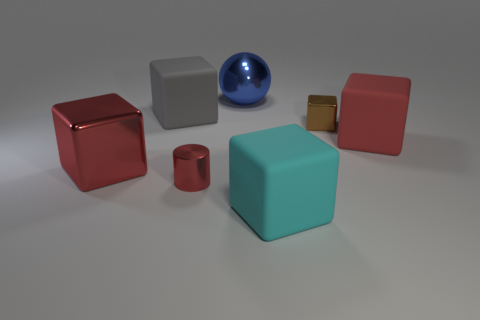Subtract all big red shiny cubes. How many cubes are left? 4 Subtract all brown blocks. How many blocks are left? 4 Subtract all green blocks. Subtract all yellow balls. How many blocks are left? 5 Add 2 metallic cylinders. How many objects exist? 9 Subtract all balls. How many objects are left? 6 Add 2 gray objects. How many gray objects are left? 3 Add 2 brown cubes. How many brown cubes exist? 3 Subtract 0 brown cylinders. How many objects are left? 7 Subtract all small brown rubber cylinders. Subtract all large metallic balls. How many objects are left? 6 